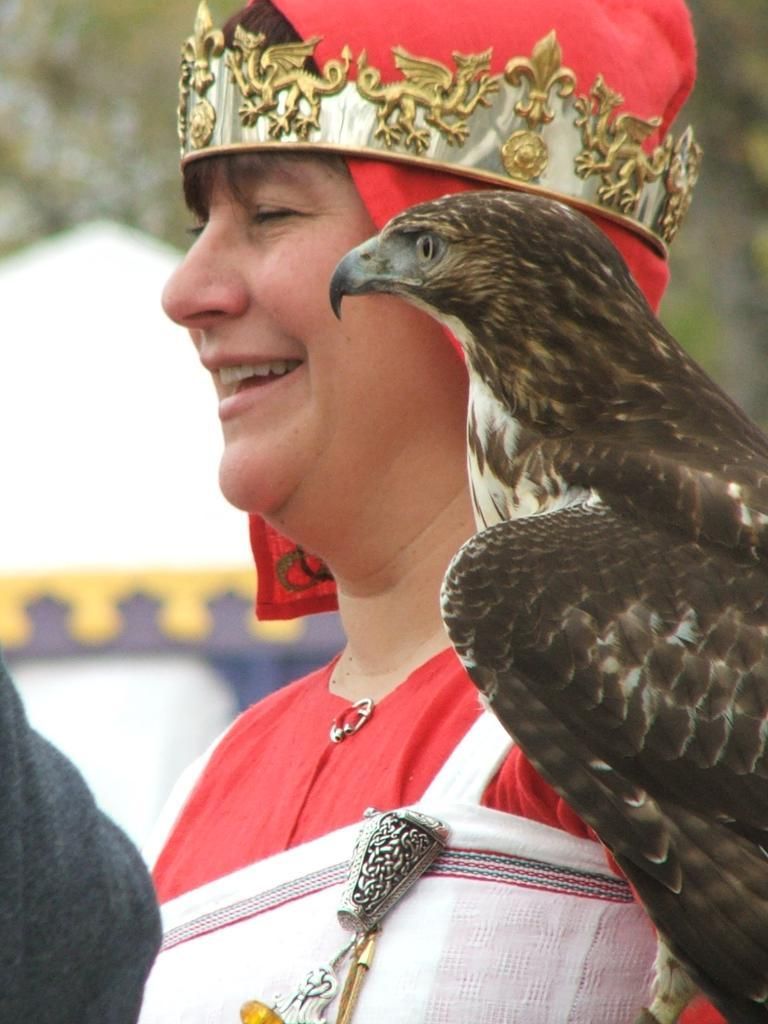What is the main subject of the image? There is a person in the image. What is the person wearing? The person is wearing a red dress. What accessory is the person wearing on their head? The person has a crown on their head. What animal is on the person's shoulder? There is an eagle on the person's shoulder. What can be seen in the background of the image? There is a tree in the background of the image. What type of nut is the person holding in their hand in the image? There is no nut visible in the person's hand in the image. Who is the person representing in the image? The image does not provide any information about the person representing someone or something. 